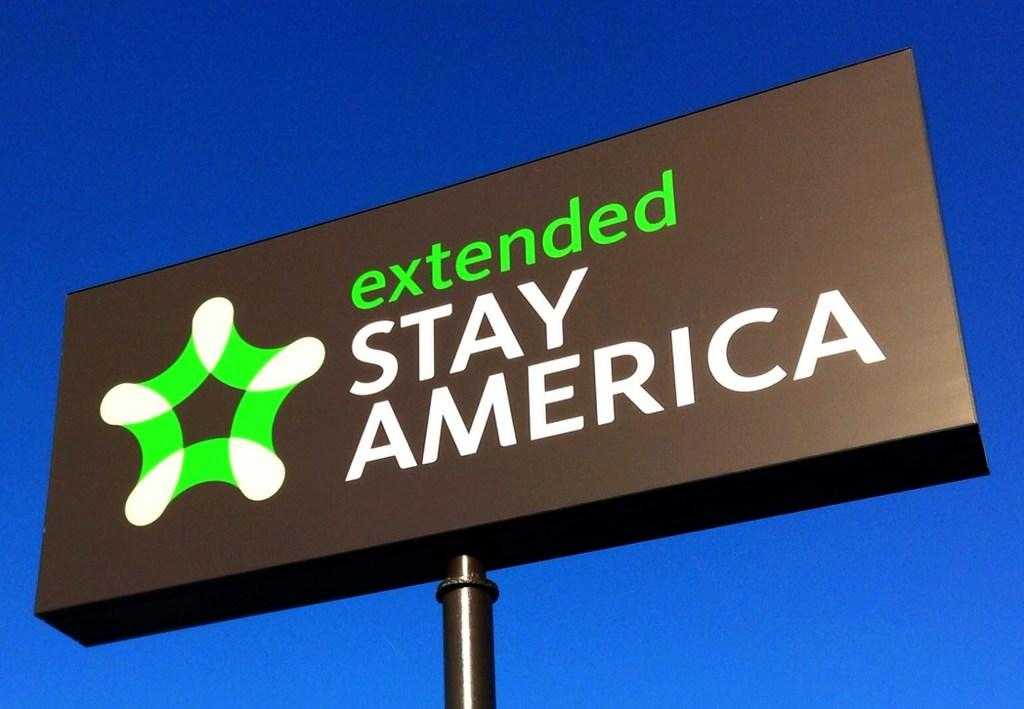Provide a one-sentence caption for the provided image. A large billboard that says extended Stay America. 